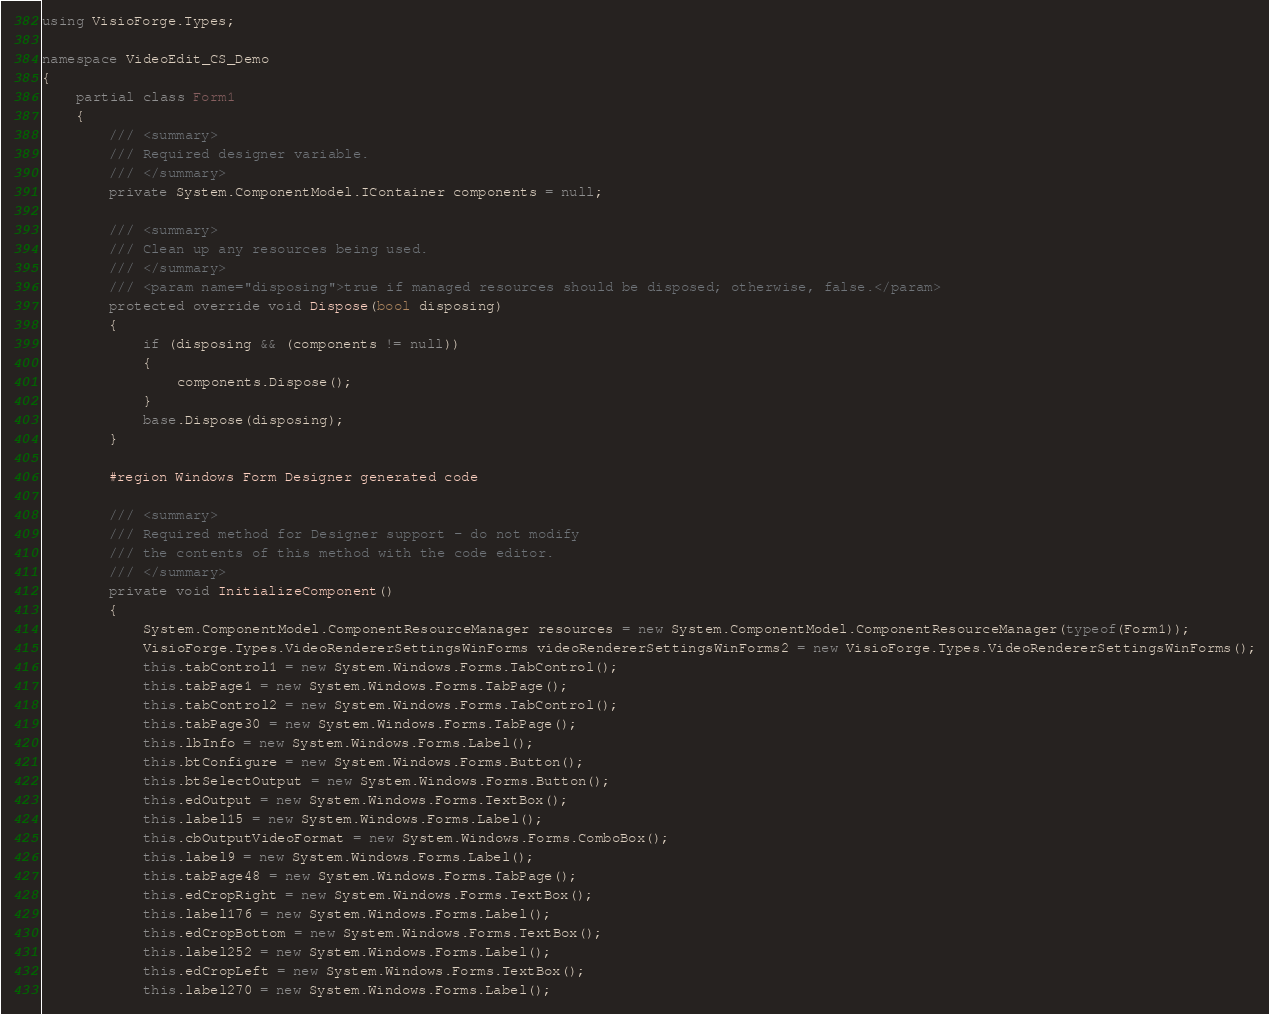<code> <loc_0><loc_0><loc_500><loc_500><_C#_>using VisioForge.Types;

namespace VideoEdit_CS_Demo
{
    partial class Form1
    {
        /// <summary>
        /// Required designer variable.
        /// </summary>
        private System.ComponentModel.IContainer components = null;

        /// <summary>
        /// Clean up any resources being used.
        /// </summary>
        /// <param name="disposing">true if managed resources should be disposed; otherwise, false.</param>
        protected override void Dispose(bool disposing)
        {
            if (disposing && (components != null))
            {
                components.Dispose();
            }
            base.Dispose(disposing);
        }

        #region Windows Form Designer generated code

        /// <summary>
        /// Required method for Designer support - do not modify
        /// the contents of this method with the code editor.
        /// </summary>
        private void InitializeComponent()
        {
            System.ComponentModel.ComponentResourceManager resources = new System.ComponentModel.ComponentResourceManager(typeof(Form1));
            VisioForge.Types.VideoRendererSettingsWinForms videoRendererSettingsWinForms2 = new VisioForge.Types.VideoRendererSettingsWinForms();
            this.tabControl1 = new System.Windows.Forms.TabControl();
            this.tabPage1 = new System.Windows.Forms.TabPage();
            this.tabControl2 = new System.Windows.Forms.TabControl();
            this.tabPage30 = new System.Windows.Forms.TabPage();
            this.lbInfo = new System.Windows.Forms.Label();
            this.btConfigure = new System.Windows.Forms.Button();
            this.btSelectOutput = new System.Windows.Forms.Button();
            this.edOutput = new System.Windows.Forms.TextBox();
            this.label15 = new System.Windows.Forms.Label();
            this.cbOutputVideoFormat = new System.Windows.Forms.ComboBox();
            this.label9 = new System.Windows.Forms.Label();
            this.tabPage48 = new System.Windows.Forms.TabPage();
            this.edCropRight = new System.Windows.Forms.TextBox();
            this.label176 = new System.Windows.Forms.Label();
            this.edCropBottom = new System.Windows.Forms.TextBox();
            this.label252 = new System.Windows.Forms.Label();
            this.edCropLeft = new System.Windows.Forms.TextBox();
            this.label270 = new System.Windows.Forms.Label();</code> 